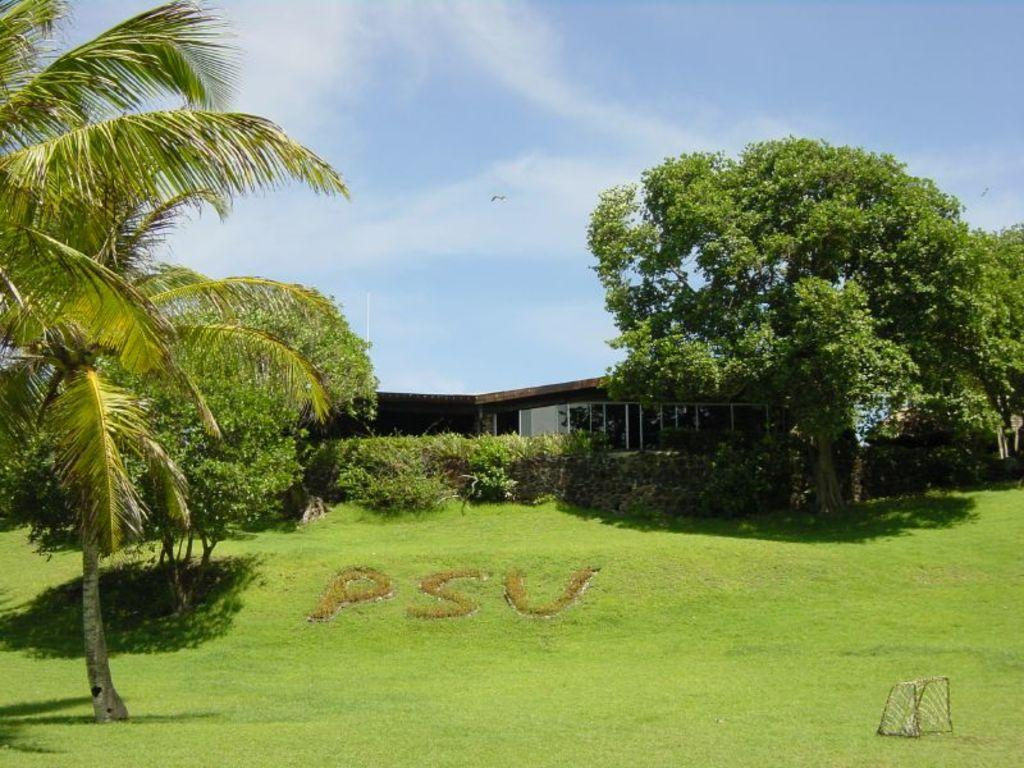What type of structure is visible in the image? There is a house in the image. What type of vegetation can be seen in the image? There are trees and plants in the image. What is at the bottom of the image? There is grass at the bottom of the image. What is visible at the top of the image? There is sky visible at the top of the image. What can be seen in the sky? There are clouds in the sky. What type of polish is being applied to the kitten in the image? There is no kitten present in the image, and therefore no polish is being applied. 